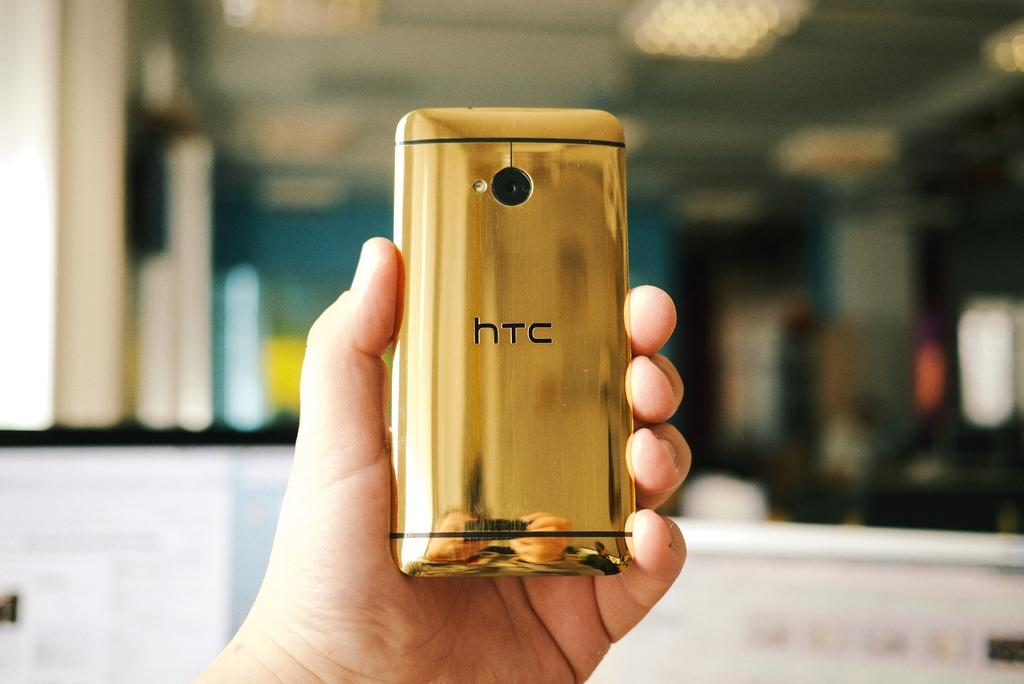<image>
Relay a brief, clear account of the picture shown. a golden HTC phone being held up by somebody 